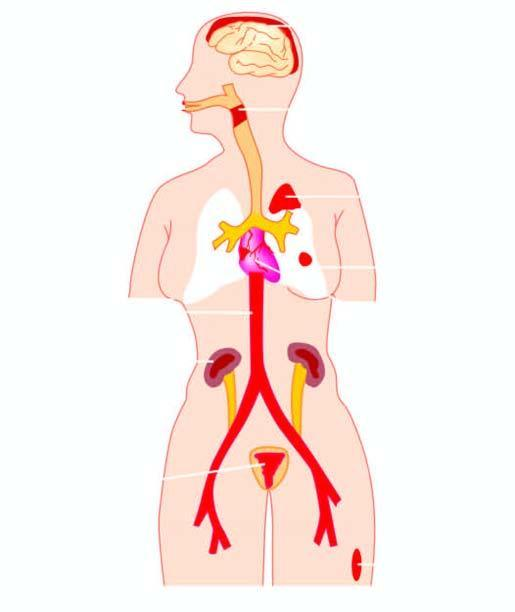how is diseases caused?
Answer the question using a single word or phrase. By streptococci 